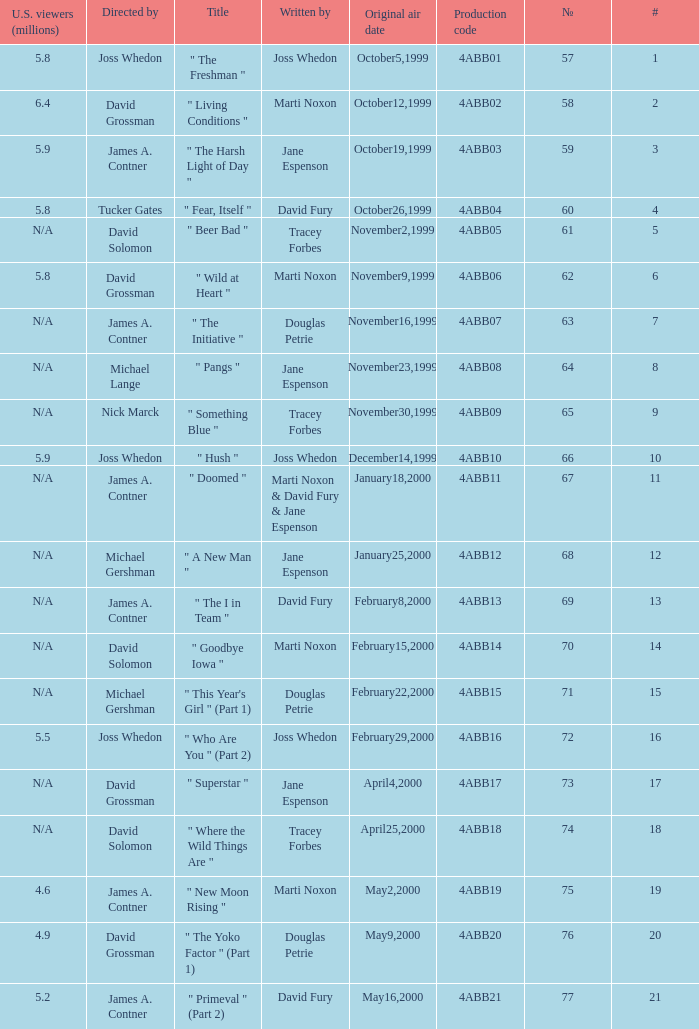What is the series No when the season 4 # is 18? 74.0. 